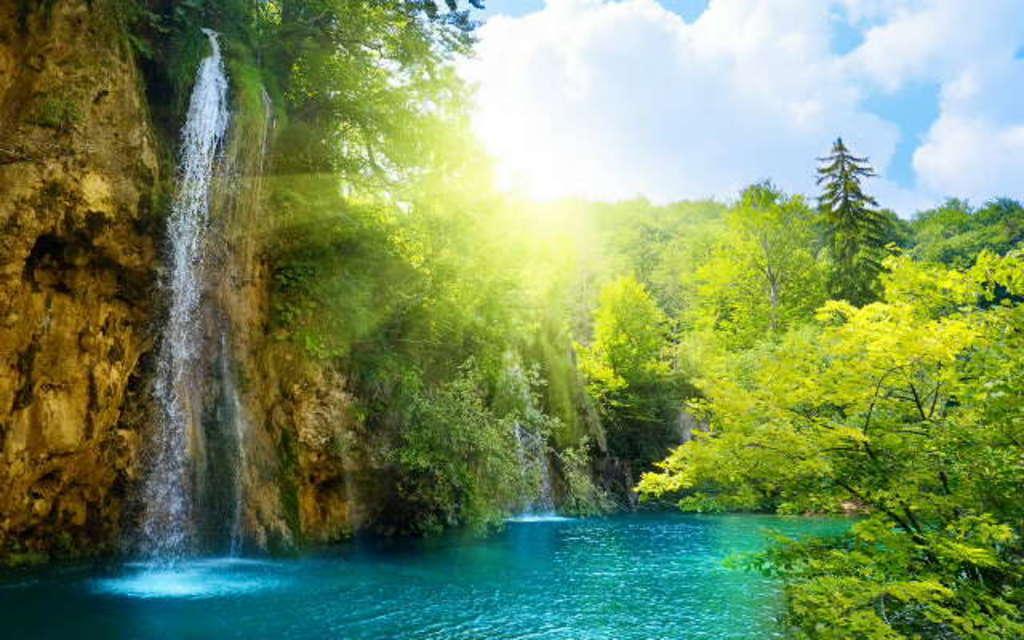Could you give a brief overview of what you see in this image? In this image I can see water, number of trees, clouds, the sky and I can also see waterfalls over here. 